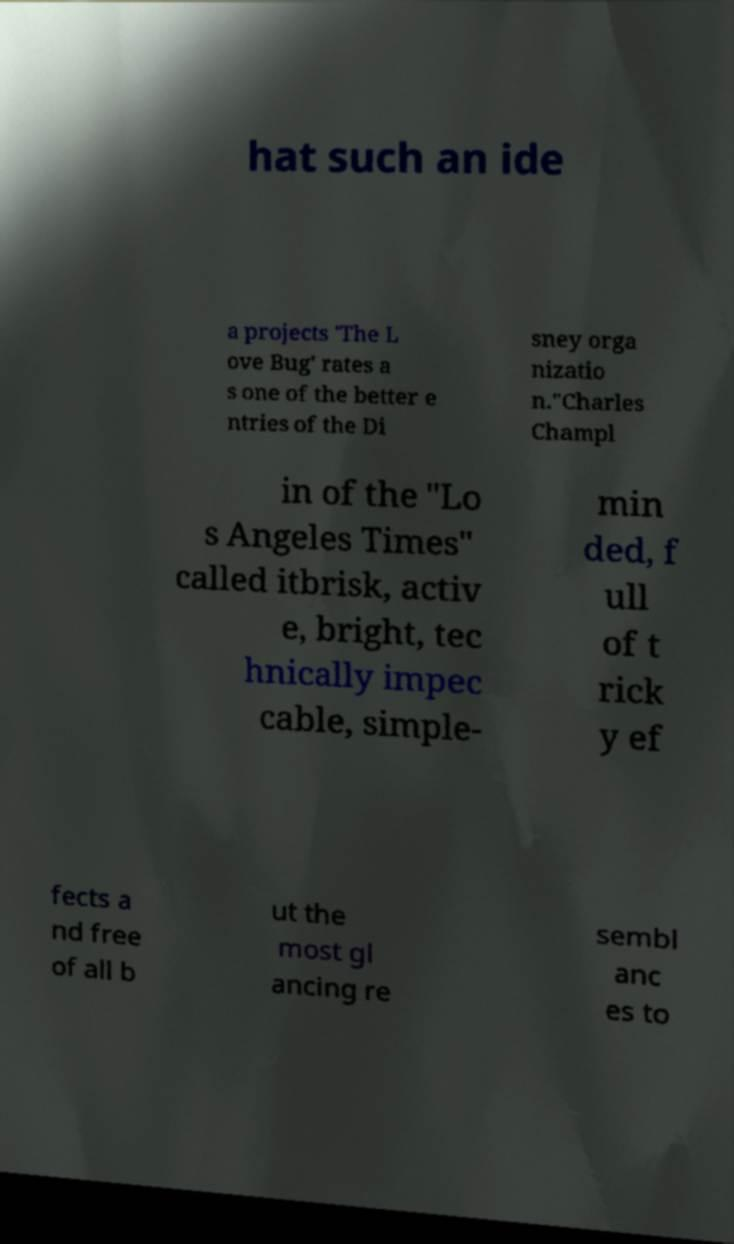Could you assist in decoding the text presented in this image and type it out clearly? hat such an ide a projects 'The L ove Bug' rates a s one of the better e ntries of the Di sney orga nizatio n."Charles Champl in of the "Lo s Angeles Times" called itbrisk, activ e, bright, tec hnically impec cable, simple- min ded, f ull of t rick y ef fects a nd free of all b ut the most gl ancing re sembl anc es to 